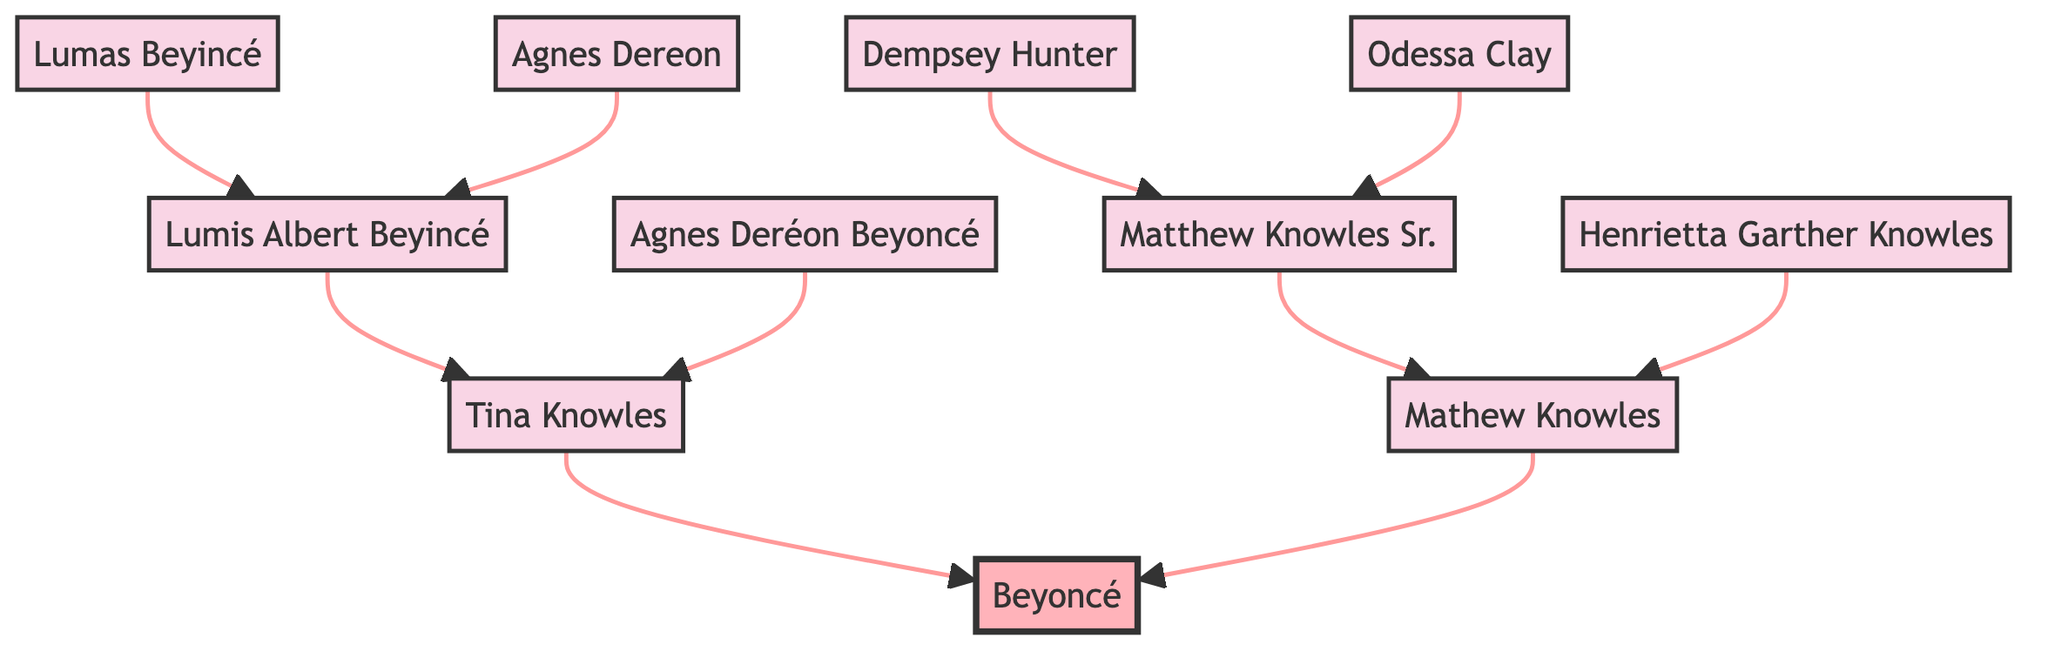What is Beyoncé’s maternal grandfather's name? The diagram shows that Beyoncé's maternal grandfather is represented by the node "Lumis Albert Beyincé." This can be directly read from the maternal lineage under "grandParents."
Answer: Lumis Albert Beyincé Who are Beyoncé's paternal grandparents? Beyoncé's paternal grandparents are listed in the diagram as "Matthew Knowles Sr." for grandfather and "Henrietta Garther Knowles" for grandmother. These nodes can be found under the paternal section of "grandParents."
Answer: Matthew Knowles Sr. and Henrietta Garther Knowles What year did Beyoncé release her debut solo album? The diagram indicates that Beyoncé released her debut solo album "Dangerously in Love" in 2003, as stated in the career milestones section. This year is highlighted in the event list connected to her career.
Answer: 2003 How many great-grandparents does Beyoncé have? The diagram shows that there are two maternal and two paternal great-grandparents, totaling to four great-grandparents. By counting the nodes under "greatGrandParents," we find two from each lineage.
Answer: 4 Which great-grandmother is part of Beyoncé's maternal lineage? The maternal great-grandmother listed in the diagram is "Agnes Dereon," and this information is visible under the maternal section of "greatGrandParents."
Answer: Agnes Dereon What milestone did Beyoncé achieve in 2018? Referring to the career milestones in the diagram, it states that in 2018, Beyoncé became the first black woman to headline Coachella, as indicated by the event listed for that year.
Answer: Became first black woman to headline Coachella What is the relationship between Mathew Knowles and Beyoncé? In the diagram, Mathew Knowles is identified as Beyoncé's father, which is shown in the parents’ section. The relationship can be traced directly from Mathew Knowles to Beyoncé in the diagram.
Answer: Father Which career milestone occurs before the “Lemonade” release? In the diagram, the career milestone just before the release of "Lemonade" in 2016 is the release of the self-titled visual album "Beyoncé" in 2013. By following the order of events in the career milestones, one can determine this sequence.
Answer: Released self-titled visual album 'Beyoncé' 